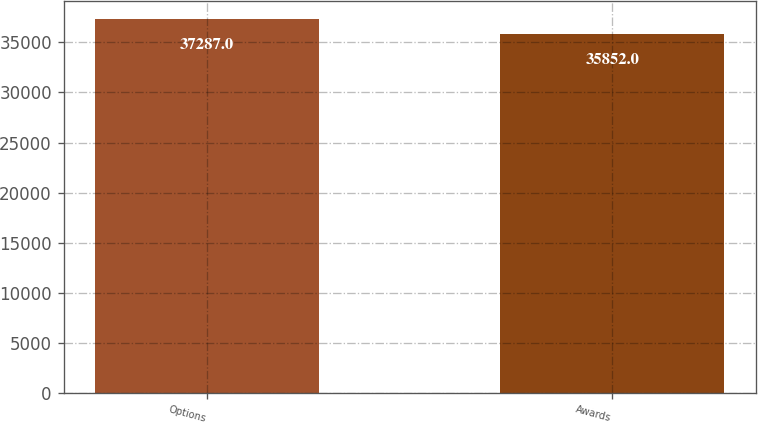Convert chart. <chart><loc_0><loc_0><loc_500><loc_500><bar_chart><fcel>Options<fcel>Awards<nl><fcel>37287<fcel>35852<nl></chart> 